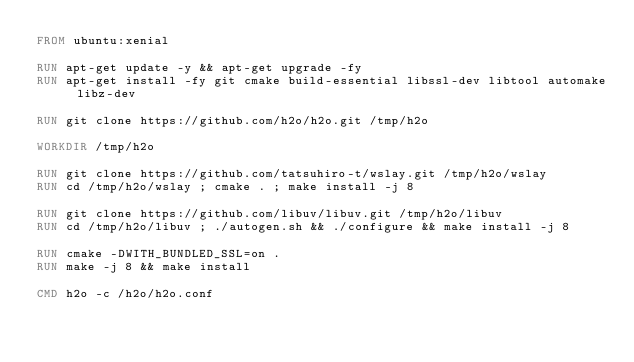Convert code to text. <code><loc_0><loc_0><loc_500><loc_500><_Dockerfile_>FROM ubuntu:xenial

RUN apt-get update -y && apt-get upgrade -fy
RUN apt-get install -fy git cmake build-essential libssl-dev libtool automake libz-dev

RUN git clone https://github.com/h2o/h2o.git /tmp/h2o

WORKDIR /tmp/h2o

RUN git clone https://github.com/tatsuhiro-t/wslay.git /tmp/h2o/wslay
RUN cd /tmp/h2o/wslay ; cmake . ; make install -j 8

RUN git clone https://github.com/libuv/libuv.git /tmp/h2o/libuv
RUN cd /tmp/h2o/libuv ; ./autogen.sh && ./configure && make install -j 8

RUN cmake -DWITH_BUNDLED_SSL=on .
RUN make -j 8 && make install

CMD h2o -c /h2o/h2o.conf
</code> 